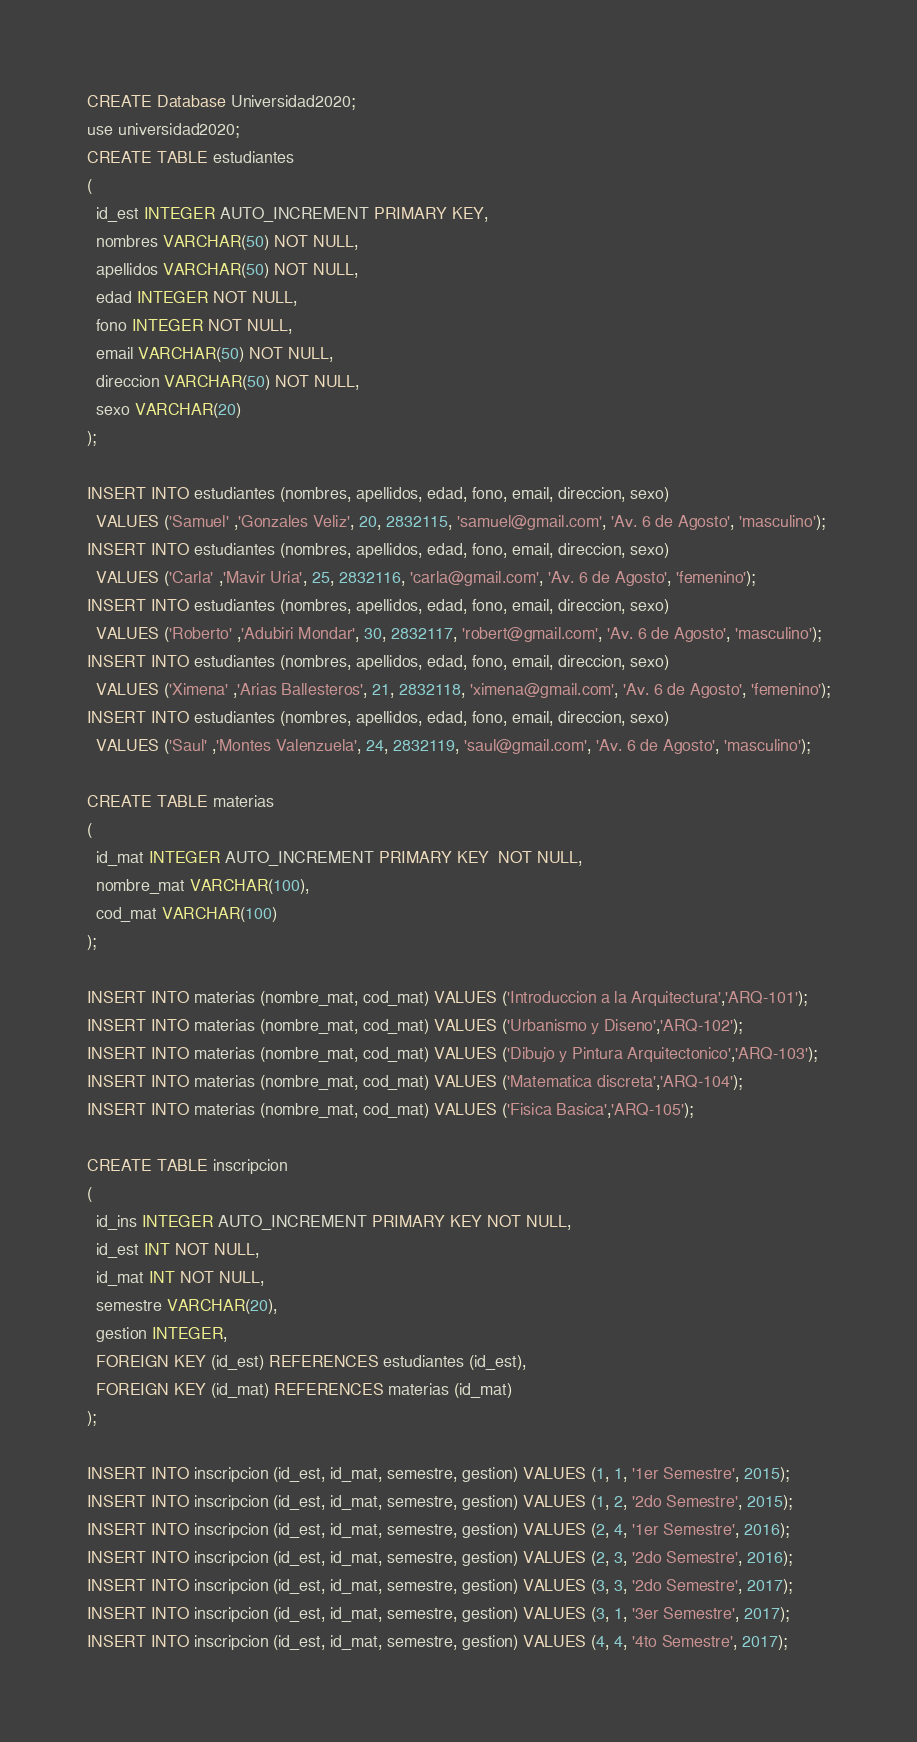Convert code to text. <code><loc_0><loc_0><loc_500><loc_500><_SQL_>CREATE Database Universidad2020;
use universidad2020;
CREATE TABLE estudiantes
(
  id_est INTEGER AUTO_INCREMENT PRIMARY KEY,
  nombres VARCHAR(50) NOT NULL,
  apellidos VARCHAR(50) NOT NULL,
  edad INTEGER NOT NULL,
  fono INTEGER NOT NULL,
  email VARCHAR(50) NOT NULL,
  direccion VARCHAR(50) NOT NULL,
  sexo VARCHAR(20)
);

INSERT INTO estudiantes (nombres, apellidos, edad, fono, email, direccion, sexo)
  VALUES ('Samuel' ,'Gonzales Veliz', 20, 2832115, 'samuel@gmail.com', 'Av. 6 de Agosto', 'masculino');
INSERT INTO estudiantes (nombres, apellidos, edad, fono, email, direccion, sexo)
  VALUES ('Carla' ,'Mavir Uria', 25, 2832116, 'carla@gmail.com', 'Av. 6 de Agosto', 'femenino');
INSERT INTO estudiantes (nombres, apellidos, edad, fono, email, direccion, sexo)
  VALUES ('Roberto' ,'Adubiri Mondar', 30, 2832117, 'robert@gmail.com', 'Av. 6 de Agosto', 'masculino');
INSERT INTO estudiantes (nombres, apellidos, edad, fono, email, direccion, sexo)
  VALUES ('Ximena' ,'Arias Ballesteros', 21, 2832118, 'ximena@gmail.com', 'Av. 6 de Agosto', 'femenino');
INSERT INTO estudiantes (nombres, apellidos, edad, fono, email, direccion, sexo)
  VALUES ('Saul' ,'Montes Valenzuela', 24, 2832119, 'saul@gmail.com', 'Av. 6 de Agosto', 'masculino');

CREATE TABLE materias
(
  id_mat INTEGER AUTO_INCREMENT PRIMARY KEY  NOT NULL,
  nombre_mat VARCHAR(100),
  cod_mat VARCHAR(100)
);

INSERT INTO materias (nombre_mat, cod_mat) VALUES ('Introduccion a la Arquitectura','ARQ-101');
INSERT INTO materias (nombre_mat, cod_mat) VALUES ('Urbanismo y Diseno','ARQ-102');
INSERT INTO materias (nombre_mat, cod_mat) VALUES ('Dibujo y Pintura Arquitectonico','ARQ-103');
INSERT INTO materias (nombre_mat, cod_mat) VALUES ('Matematica discreta','ARQ-104');
INSERT INTO materias (nombre_mat, cod_mat) VALUES ('Fisica Basica','ARQ-105');

CREATE TABLE inscripcion
(
  id_ins INTEGER AUTO_INCREMENT PRIMARY KEY NOT NULL,
  id_est INT NOT NULL,
  id_mat INT NOT NULL,
  semestre VARCHAR(20),
  gestion INTEGER,
  FOREIGN KEY (id_est) REFERENCES estudiantes (id_est),
  FOREIGN KEY (id_mat) REFERENCES materias (id_mat)
);

INSERT INTO inscripcion (id_est, id_mat, semestre, gestion) VALUES (1, 1, '1er Semestre', 2015);
INSERT INTO inscripcion (id_est, id_mat, semestre, gestion) VALUES (1, 2, '2do Semestre', 2015);
INSERT INTO inscripcion (id_est, id_mat, semestre, gestion) VALUES (2, 4, '1er Semestre', 2016);
INSERT INTO inscripcion (id_est, id_mat, semestre, gestion) VALUES (2, 3, '2do Semestre', 2016);
INSERT INTO inscripcion (id_est, id_mat, semestre, gestion) VALUES (3, 3, '2do Semestre', 2017);
INSERT INTO inscripcion (id_est, id_mat, semestre, gestion) VALUES (3, 1, '3er Semestre', 2017);
INSERT INTO inscripcion (id_est, id_mat, semestre, gestion) VALUES (4, 4, '4to Semestre', 2017);</code> 